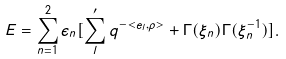<formula> <loc_0><loc_0><loc_500><loc_500>E = \sum _ { n = 1 } ^ { 2 } \epsilon _ { n } [ \sum _ { l } ^ { \prime } q ^ { - < e _ { l } , \rho > } + \Gamma ( \xi _ { n } ) \Gamma ( { \xi } _ { n } ^ { - 1 } ) ] .</formula> 